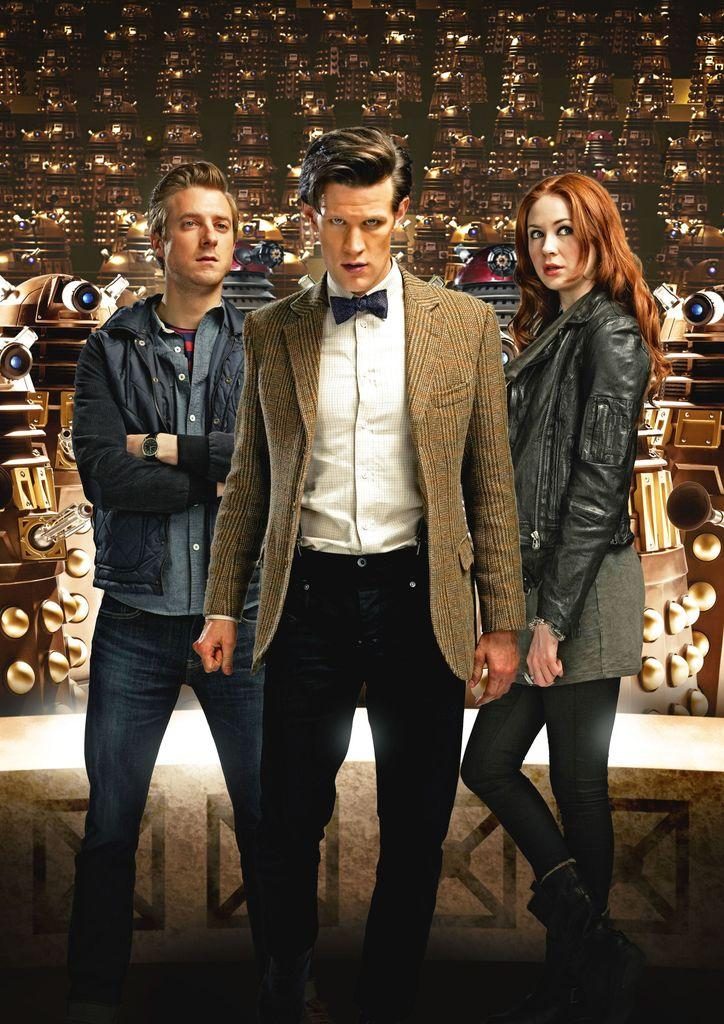How many people are in the image? There are two men and a woman in the image. What is the man in the middle wearing? The man in the middle is wearing a suit, shirt, and pants. What type of clothing is the woman wearing? The woman is wearing a jacket. What hill can be seen in the background of the image? There is no hill visible in the image. 